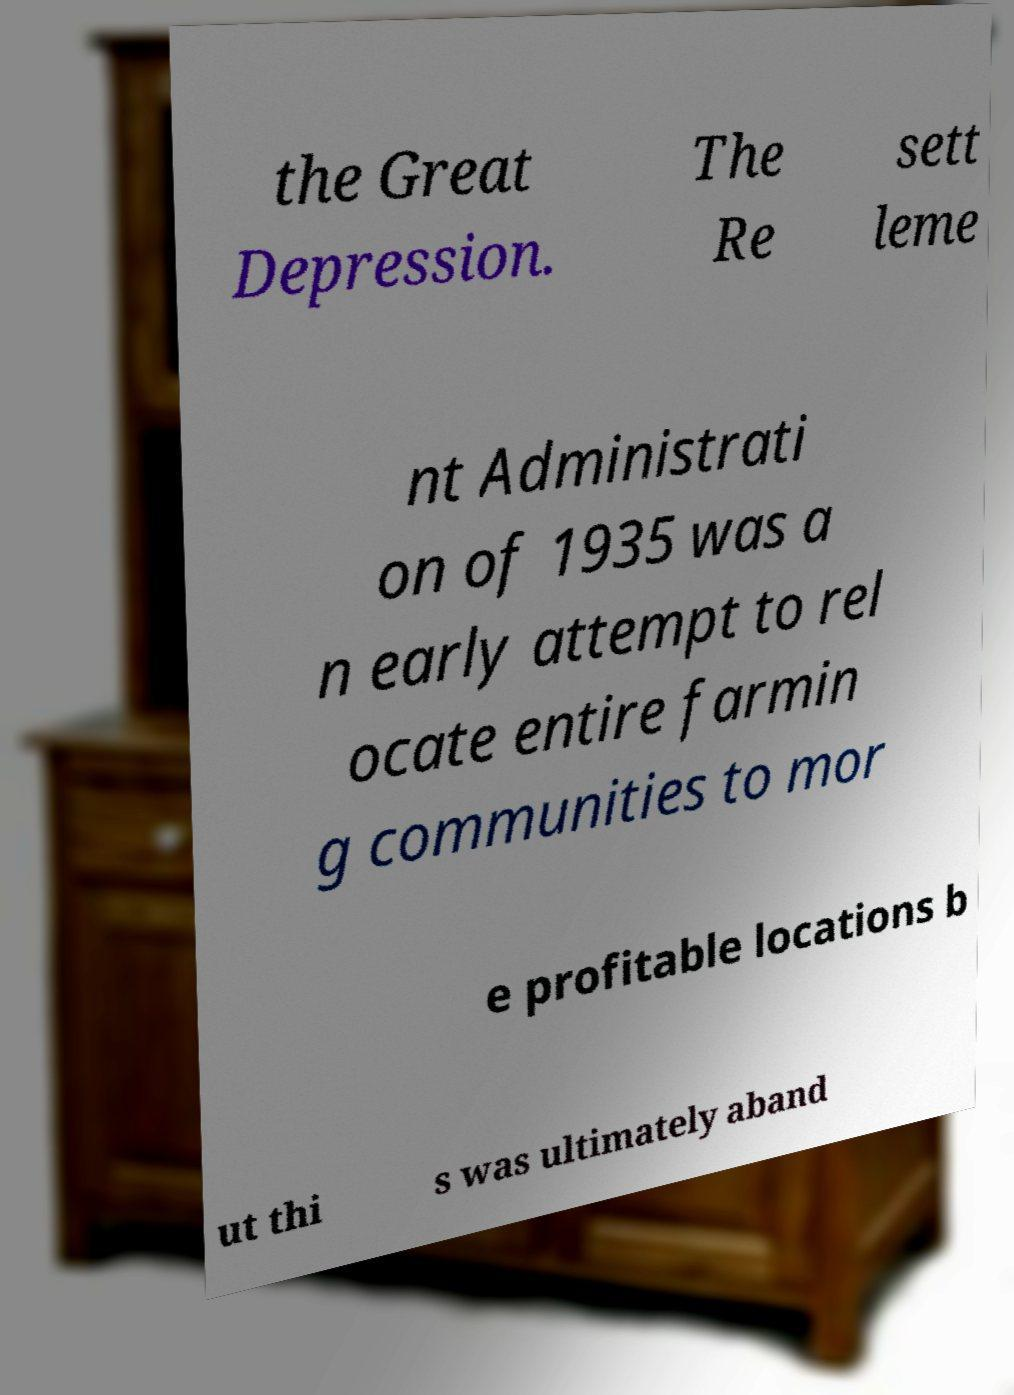Can you read and provide the text displayed in the image?This photo seems to have some interesting text. Can you extract and type it out for me? the Great Depression. The Re sett leme nt Administrati on of 1935 was a n early attempt to rel ocate entire farmin g communities to mor e profitable locations b ut thi s was ultimately aband 